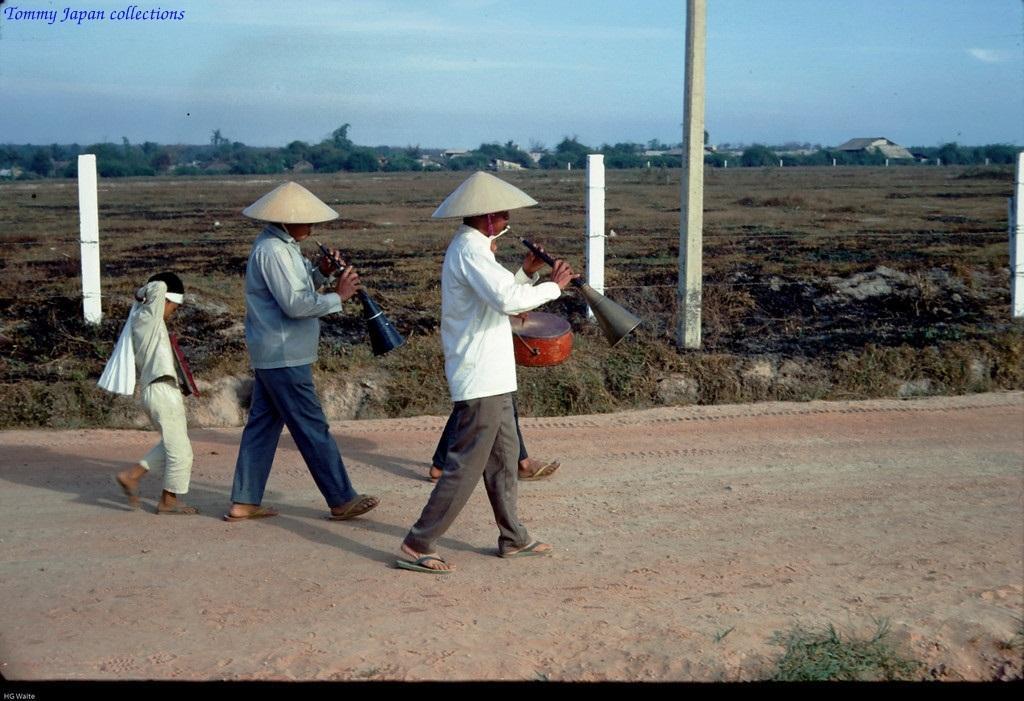Could you give a brief overview of what you see in this image? In this image I can see few people are walking and holding musical instruments. Back I can see few trees,houses and fencing. The sky is in blue and white color. 